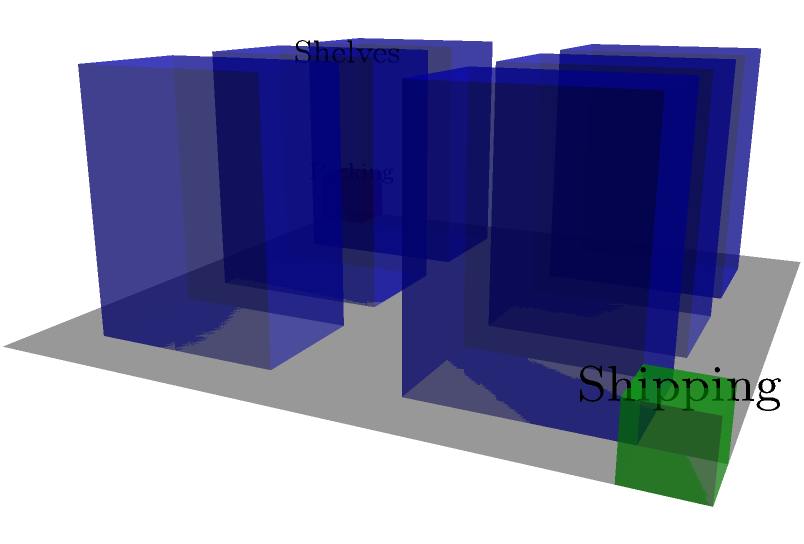As an entrepreneur optimizing your warehouse layout, you're considering a new 3D spatial arrangement. The diagram shows a warehouse floor plan with shelving units (blue), a packing station (red), and a shipping area (green). If you need to maximize the number of shelving units while maintaining efficient paths for order fulfillment, which configuration would be most effective?

A) Keep the current layout
B) Rotate shelves 90 degrees
C) Stack shelves vertically
D) Arrange shelves in a U-shape To optimize the warehouse layout for efficiency and capacity, we need to consider several factors:

1. Space utilization: The current layout uses space efficiently but leaves some areas unused.

2. Order fulfillment path: The current layout allows for relatively straight paths from shelves to packing and shipping areas.

3. Accessibility: All shelves are easily accessible in the current layout.

4. Vertical space: The current layout doesn't fully utilize the vertical space available in the warehouse.

5. Flexibility: The current layout allows for easy modification and adaptation.

Analyzing the options:

A) Keeping the current layout maintains the existing efficiency but doesn't improve capacity.

B) Rotating shelves 90 degrees might create inefficient paths and reduce accessibility.

C) Stacking shelves vertically would significantly increase storage capacity while maintaining the efficient layout. This option makes the best use of available vertical space without compromising accessibility or order fulfillment paths.

D) Arranging shelves in a U-shape might improve space utilization but could create longer, less efficient paths for order fulfillment.

Given these considerations, option C (stacking shelves vertically) provides the best balance of increased capacity and maintained efficiency. It allows for more storage without significantly altering the efficient paths between shelves, packing, and shipping areas.
Answer: C) Stack shelves vertically 